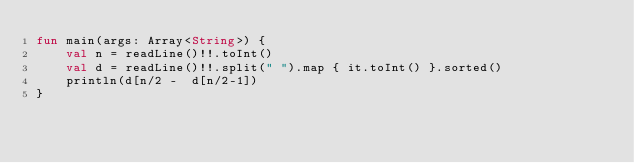Convert code to text. <code><loc_0><loc_0><loc_500><loc_500><_Kotlin_>fun main(args: Array<String>) {
    val n = readLine()!!.toInt()
    val d = readLine()!!.split(" ").map { it.toInt() }.sorted()
    println(d[n/2 -  d[n/2-1])
}
</code> 